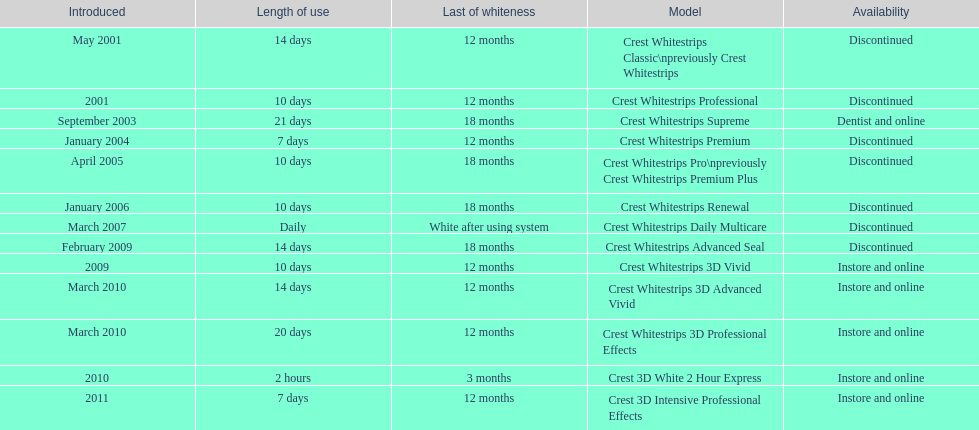How many models require less than a week of use? 2. 